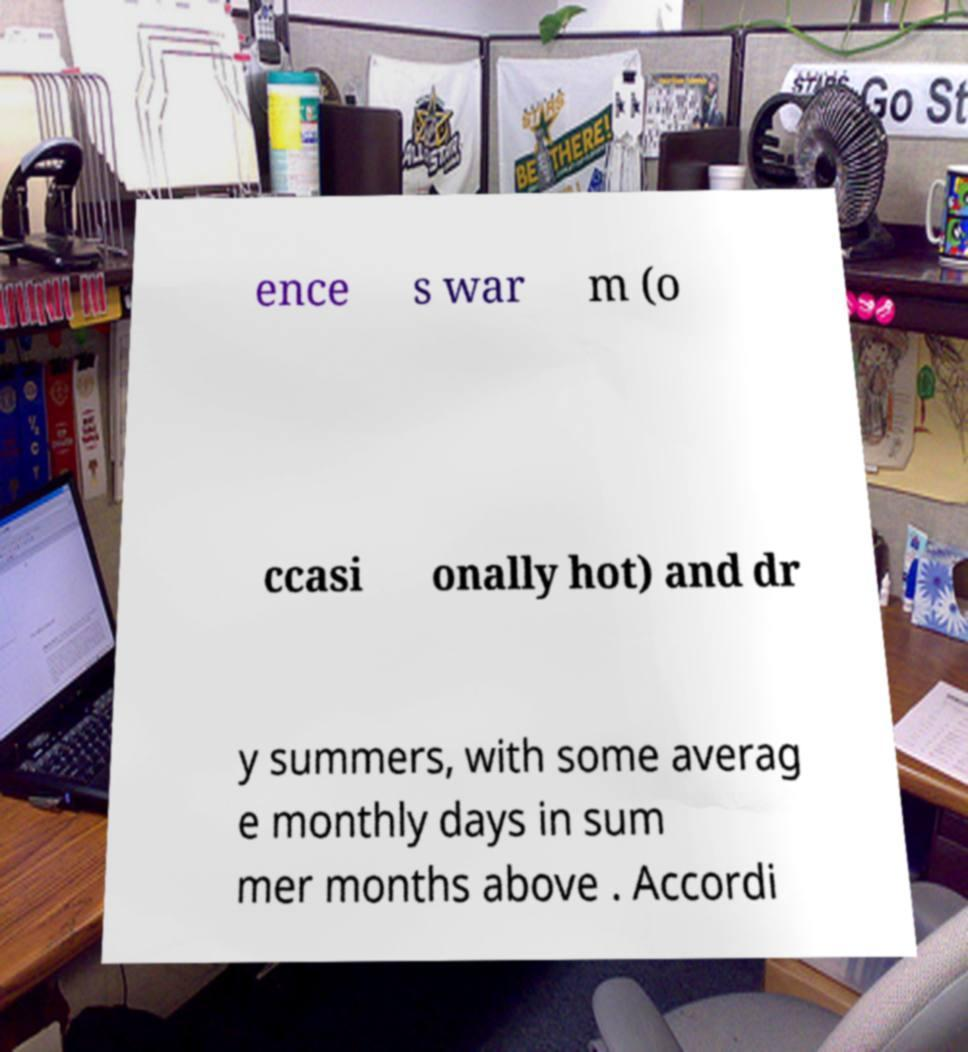Can you accurately transcribe the text from the provided image for me? ence s war m (o ccasi onally hot) and dr y summers, with some averag e monthly days in sum mer months above . Accordi 